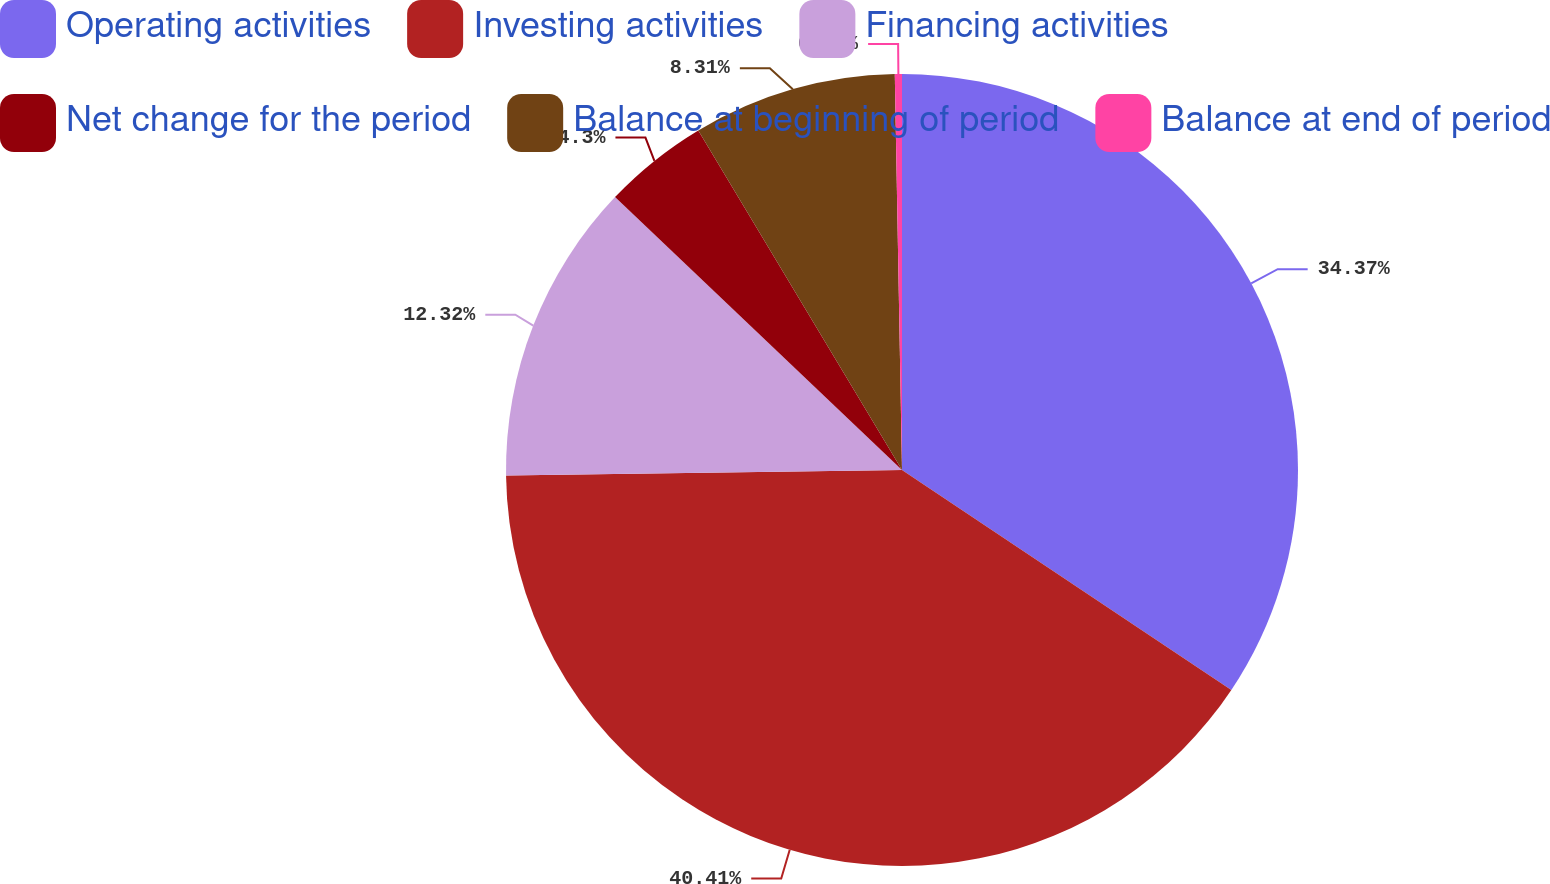<chart> <loc_0><loc_0><loc_500><loc_500><pie_chart><fcel>Operating activities<fcel>Investing activities<fcel>Financing activities<fcel>Net change for the period<fcel>Balance at beginning of period<fcel>Balance at end of period<nl><fcel>34.37%<fcel>40.41%<fcel>12.32%<fcel>4.3%<fcel>8.31%<fcel>0.29%<nl></chart> 